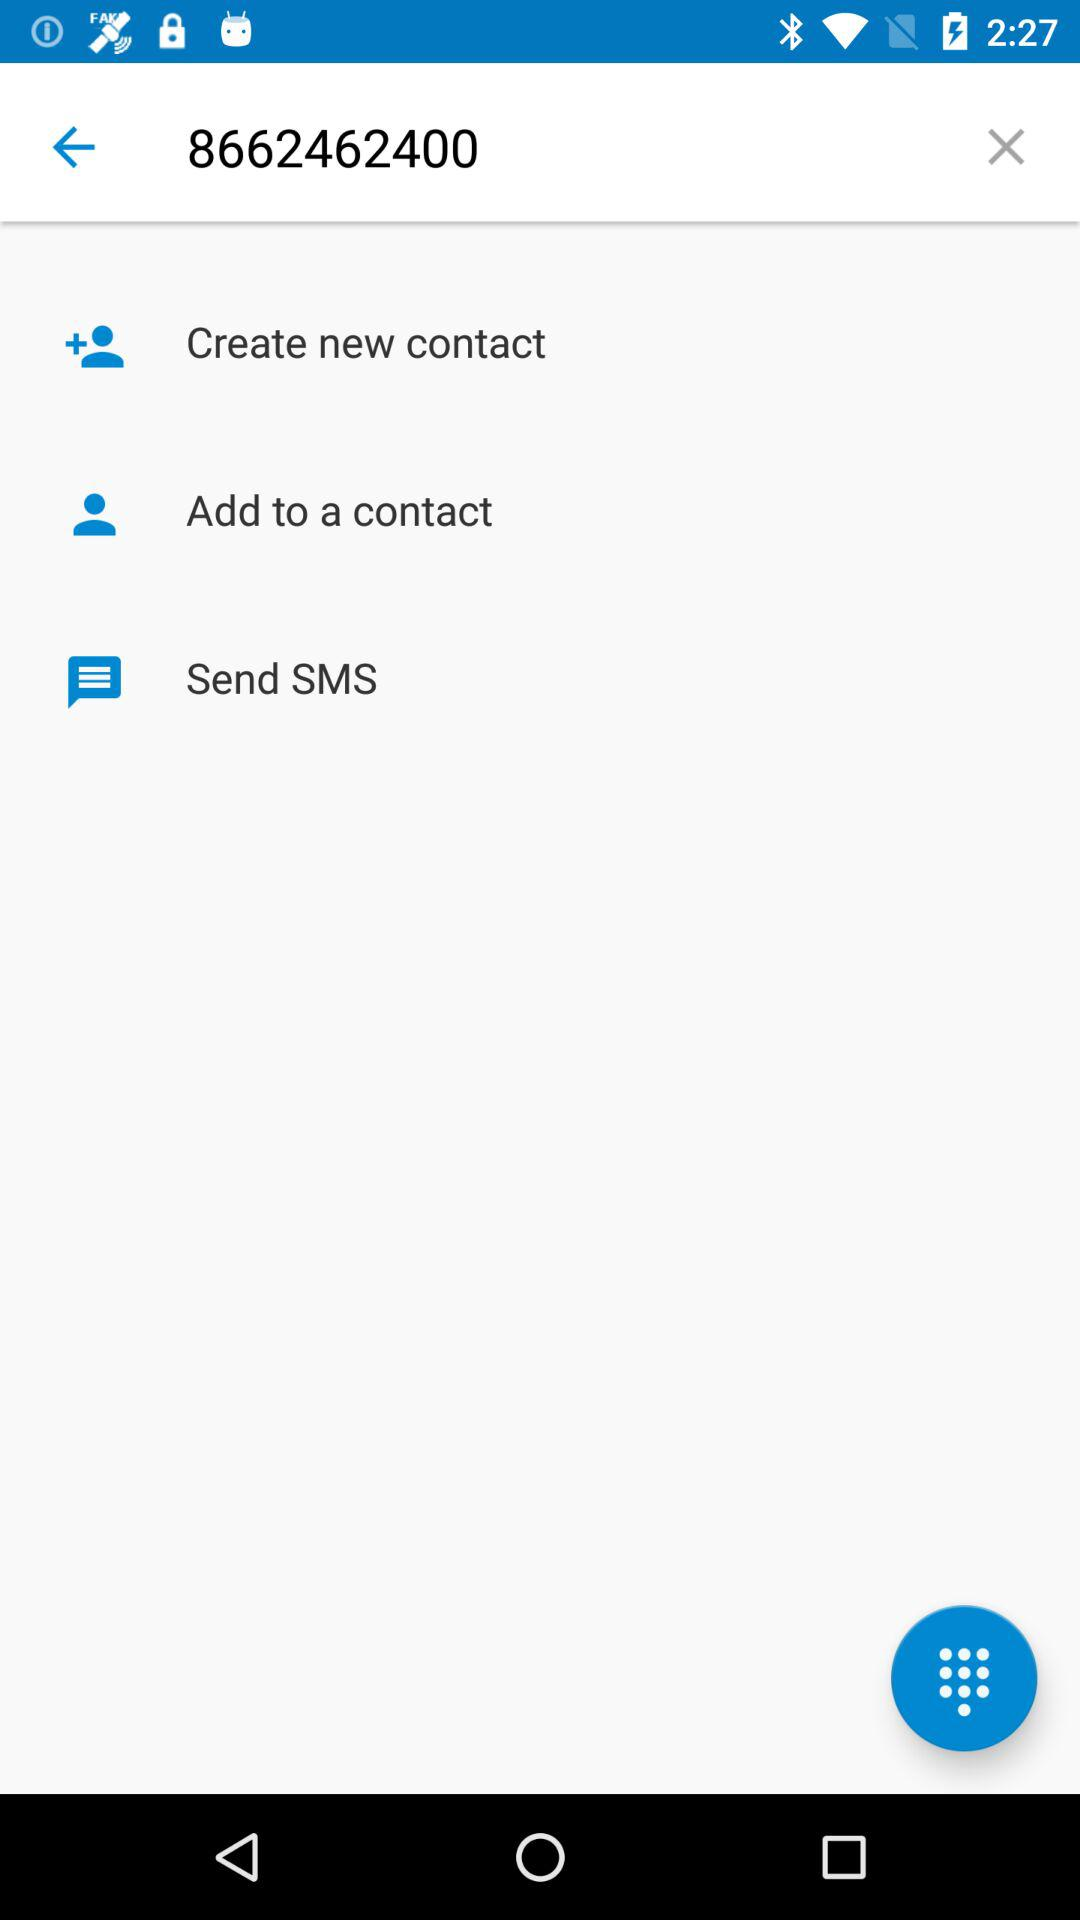What is the phone number? The phone number is 8662462400. 